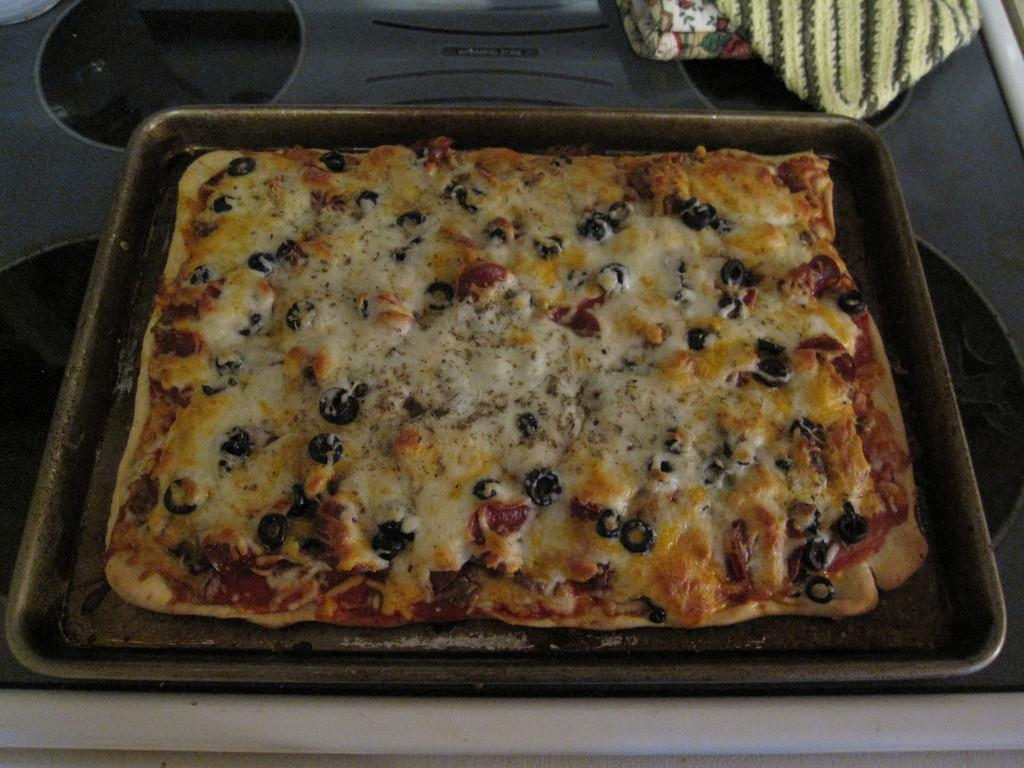What is the main object in the center of the image? There is a tray in the center of the image. What is on the tray? The tray contains pizza. Where is the tray located in relation to other objects in the image? The tray is on a table at the bottom of the image. What else can be seen in the image besides the tray and pizza? Clothes are visible at the top of the image. How many buttons are on the pizza in the image? There are no buttons on the pizza in the image; it is a regular pizza. What is the hour depicted in the image? There is no clock or indication of time in the image. 